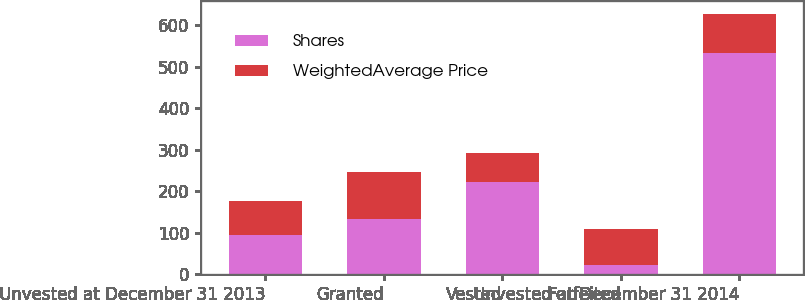Convert chart to OTSL. <chart><loc_0><loc_0><loc_500><loc_500><stacked_bar_chart><ecel><fcel>Unvested at December 31 2013<fcel>Granted<fcel>Vested<fcel>Forfeited<fcel>Unvested at December 31 2014<nl><fcel>Shares<fcel>94.38<fcel>134<fcel>222<fcel>21<fcel>533<nl><fcel>WeightedAverage Price<fcel>82.16<fcel>112.59<fcel>70.69<fcel>87.43<fcel>94.38<nl></chart> 